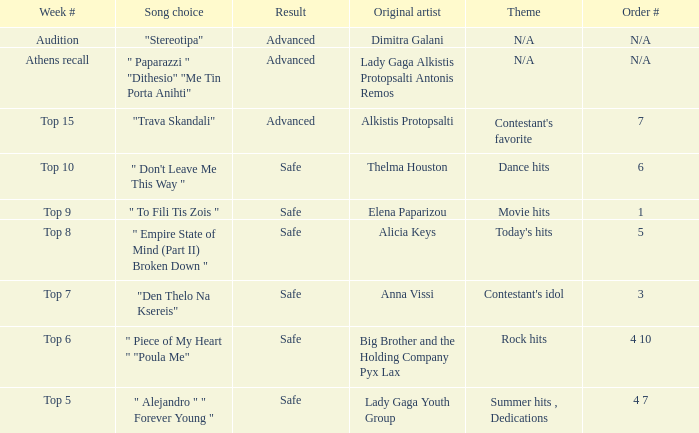Which artists have order number 6? Thelma Houston. 